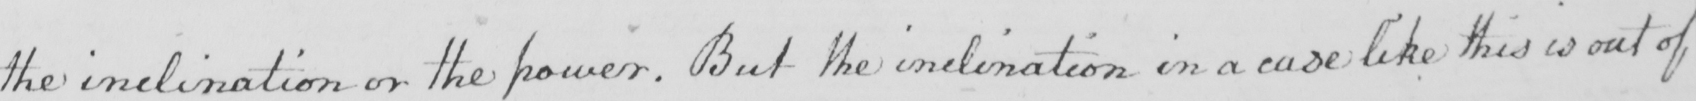Can you read and transcribe this handwriting? the inclination or the power . But the inclination in a case like this is out of 